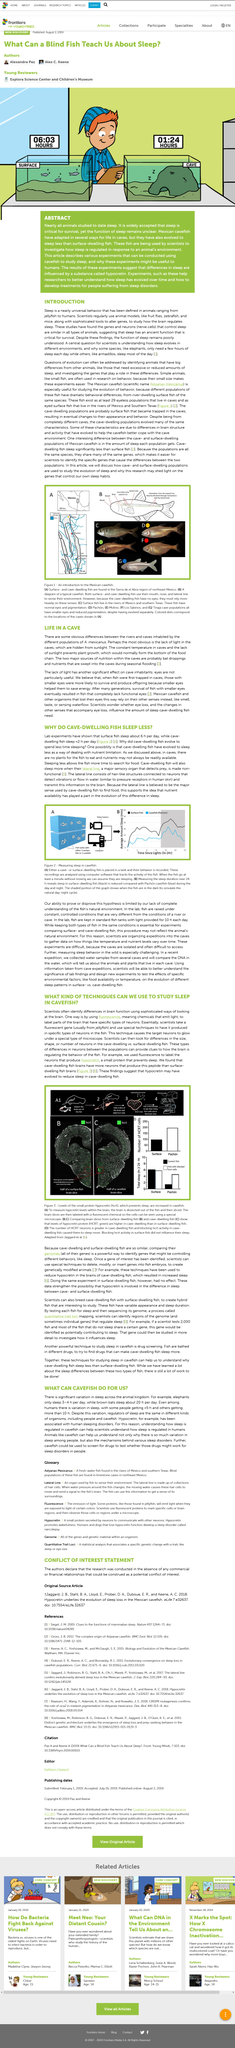List a handful of essential elements in this visual. Surface- and cave-dwelling fish utilize their mouth, nose, and lateral line as sensory organs to perceive their surroundings. In the Sierra de el Abra region of northeast Mexico, surface- and cave-dwelling fish can be found. These fish live in both the surface waters and in the caves of the region. The lateral line is the major sensory organ that detects prey for many aquatic animals. It is an efficient and versatile sensory system that allows fish and other aquatic creatures to detect water movements, vibrations, and changes in pressure, enabling them to detect and respond to potential threats or prey. The article discusses studying the phenomenon of sleep in cavefish, as indicated by the title. A recent study indicates that hypocretin, which is responsible for regulating wakefulness in vertebrates, may have evolved to help cave-dwelling fish conserve energy by reducing their sleeping hours. 